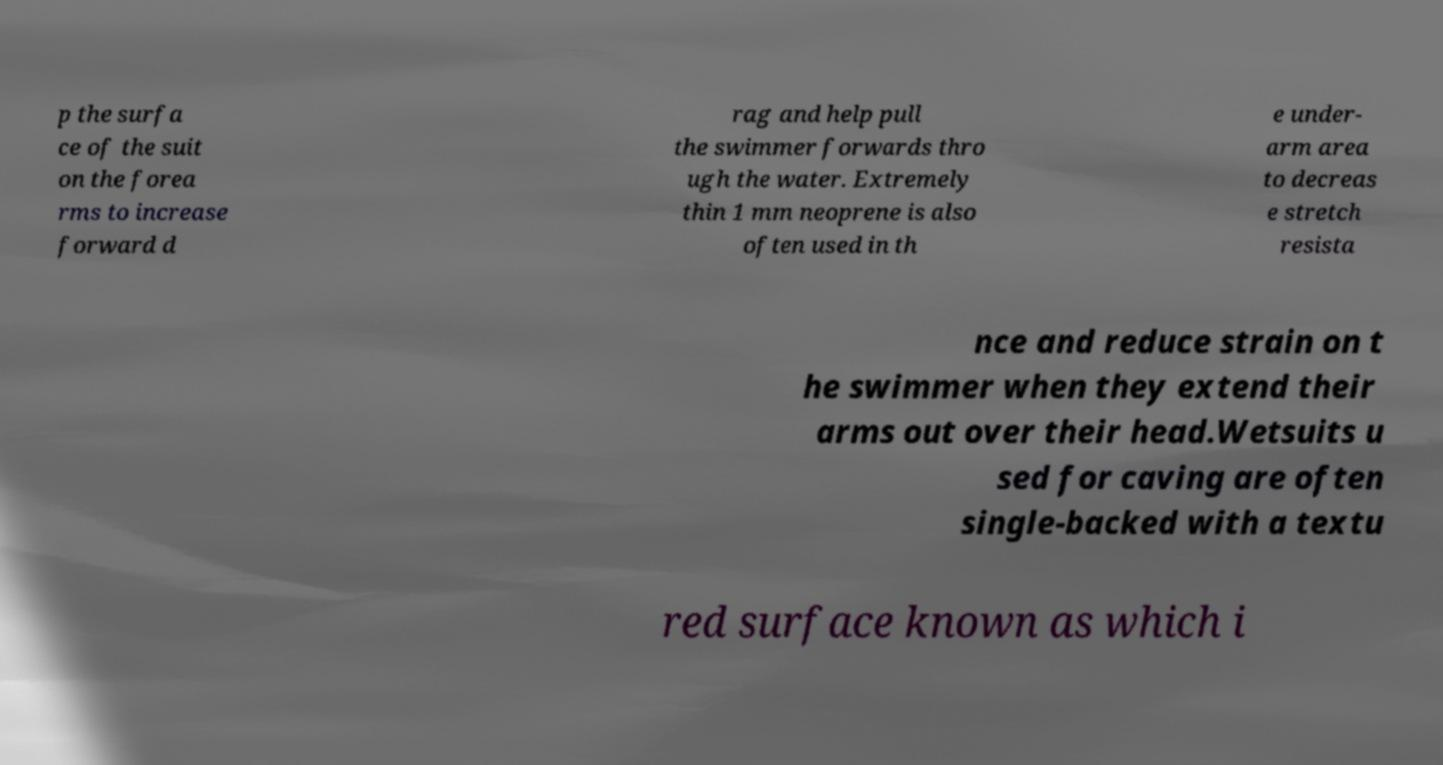Can you accurately transcribe the text from the provided image for me? p the surfa ce of the suit on the forea rms to increase forward d rag and help pull the swimmer forwards thro ugh the water. Extremely thin 1 mm neoprene is also often used in th e under- arm area to decreas e stretch resista nce and reduce strain on t he swimmer when they extend their arms out over their head.Wetsuits u sed for caving are often single-backed with a textu red surface known as which i 